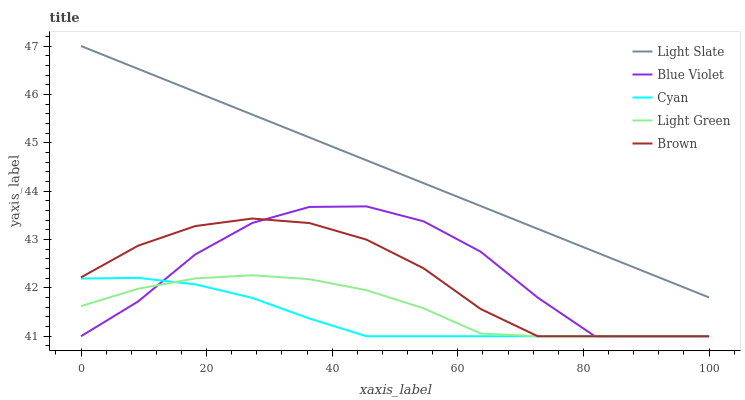Does Cyan have the minimum area under the curve?
Answer yes or no. Yes. Does Light Slate have the maximum area under the curve?
Answer yes or no. Yes. Does Light Green have the minimum area under the curve?
Answer yes or no. No. Does Light Green have the maximum area under the curve?
Answer yes or no. No. Is Light Slate the smoothest?
Answer yes or no. Yes. Is Blue Violet the roughest?
Answer yes or no. Yes. Is Cyan the smoothest?
Answer yes or no. No. Is Cyan the roughest?
Answer yes or no. No. Does Cyan have the lowest value?
Answer yes or no. Yes. Does Light Slate have the highest value?
Answer yes or no. Yes. Does Light Green have the highest value?
Answer yes or no. No. Is Cyan less than Light Slate?
Answer yes or no. Yes. Is Light Slate greater than Blue Violet?
Answer yes or no. Yes. Does Light Green intersect Brown?
Answer yes or no. Yes. Is Light Green less than Brown?
Answer yes or no. No. Is Light Green greater than Brown?
Answer yes or no. No. Does Cyan intersect Light Slate?
Answer yes or no. No. 